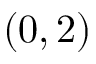<formula> <loc_0><loc_0><loc_500><loc_500>( 0 , 2 )</formula> 